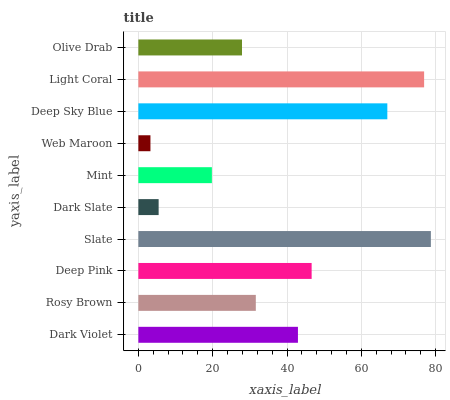Is Web Maroon the minimum?
Answer yes or no. Yes. Is Slate the maximum?
Answer yes or no. Yes. Is Rosy Brown the minimum?
Answer yes or no. No. Is Rosy Brown the maximum?
Answer yes or no. No. Is Dark Violet greater than Rosy Brown?
Answer yes or no. Yes. Is Rosy Brown less than Dark Violet?
Answer yes or no. Yes. Is Rosy Brown greater than Dark Violet?
Answer yes or no. No. Is Dark Violet less than Rosy Brown?
Answer yes or no. No. Is Dark Violet the high median?
Answer yes or no. Yes. Is Rosy Brown the low median?
Answer yes or no. Yes. Is Deep Pink the high median?
Answer yes or no. No. Is Dark Violet the low median?
Answer yes or no. No. 